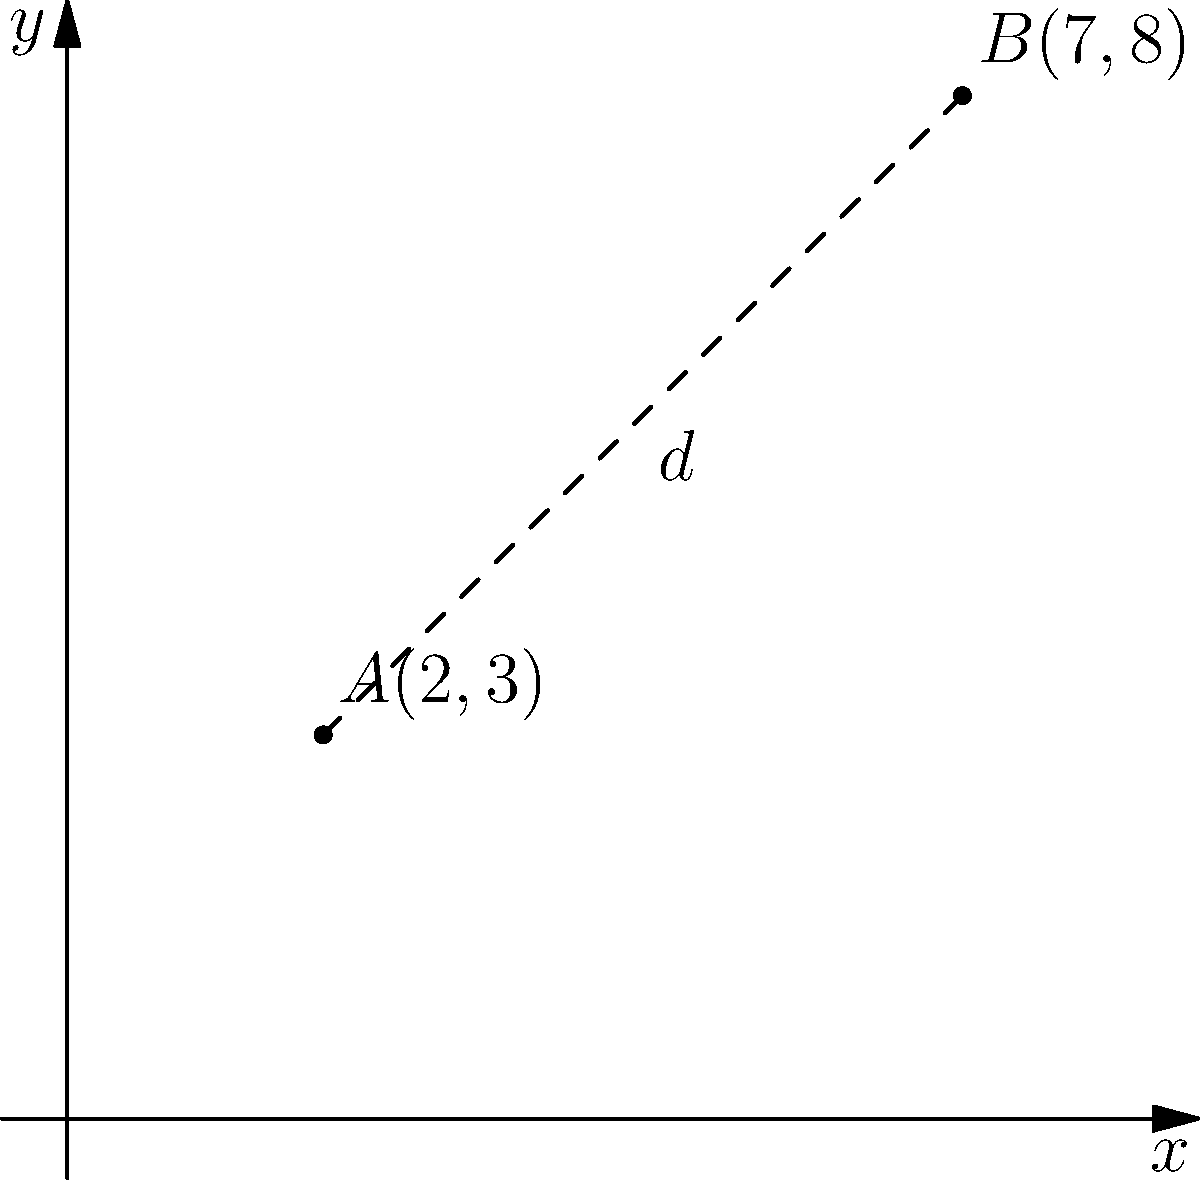En una escena de la película clásica "Los Olvidados" de Luis Buñuel, dos personajes se encuentran en diferentes puntos de un plano cartesiano. El personaje principal, Pedro, está en el punto $A(2,3)$, mientras que el antagonista, Jaibo, está en el punto $B(7,8)$. ¿Cuál es la distancia entre estos dos personajes en el plano? Para calcular la distancia entre dos puntos en un plano cartesiano, utilizamos la fórmula de la distancia:

$$d = \sqrt{(x_2 - x_1)^2 + (y_2 - y_1)^2}$$

Donde $(x_1, y_1)$ son las coordenadas del primer punto y $(x_2, y_2)$ son las coordenadas del segundo punto.

Paso 1: Identificar las coordenadas
$A(x_1, y_1) = (2, 3)$
$B(x_2, y_2) = (7, 8)$

Paso 2: Aplicar la fórmula
$$d = \sqrt{(7 - 2)^2 + (8 - 3)^2}$$

Paso 3: Calcular las diferencias dentro de los paréntesis
$$d = \sqrt{5^2 + 5^2}$$

Paso 4: Calcular los cuadrados
$$d = \sqrt{25 + 25}$$

Paso 5: Sumar dentro de la raíz cuadrada
$$d = \sqrt{50}$$

Paso 6: Simplificar la raíz cuadrada
$$d = 5\sqrt{2}$$

Por lo tanto, la distancia entre Pedro y Jaibo en la escena es $5\sqrt{2}$ unidades.
Answer: $5\sqrt{2}$ unidades 